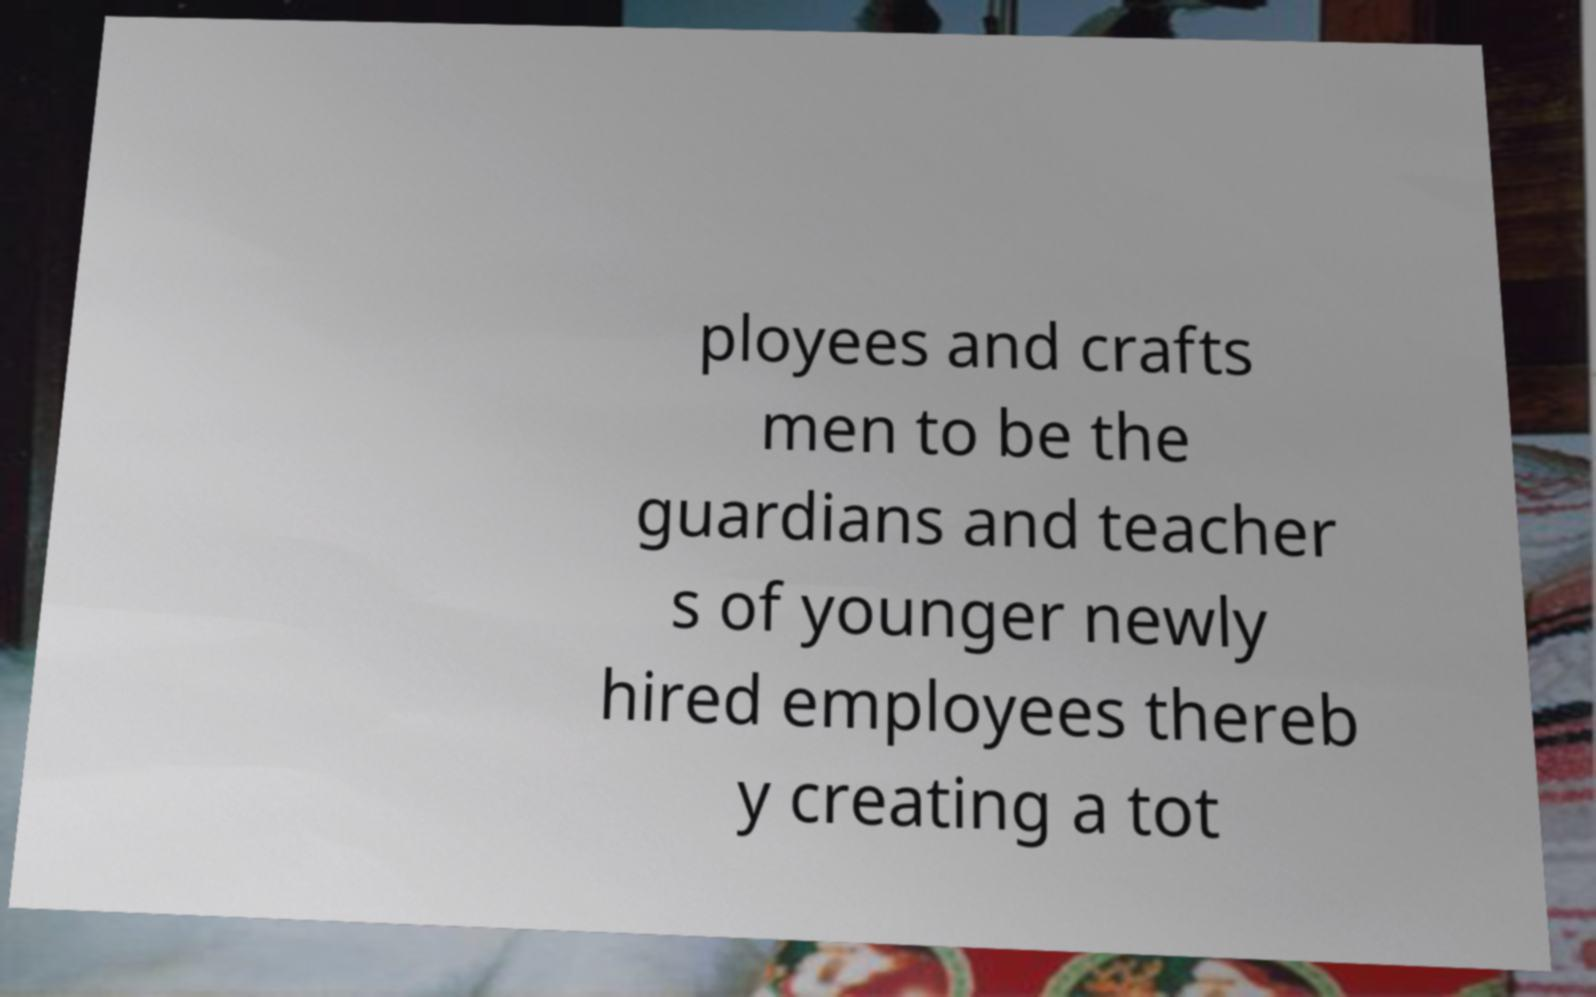I need the written content from this picture converted into text. Can you do that? ployees and crafts men to be the guardians and teacher s of younger newly hired employees thereb y creating a tot 